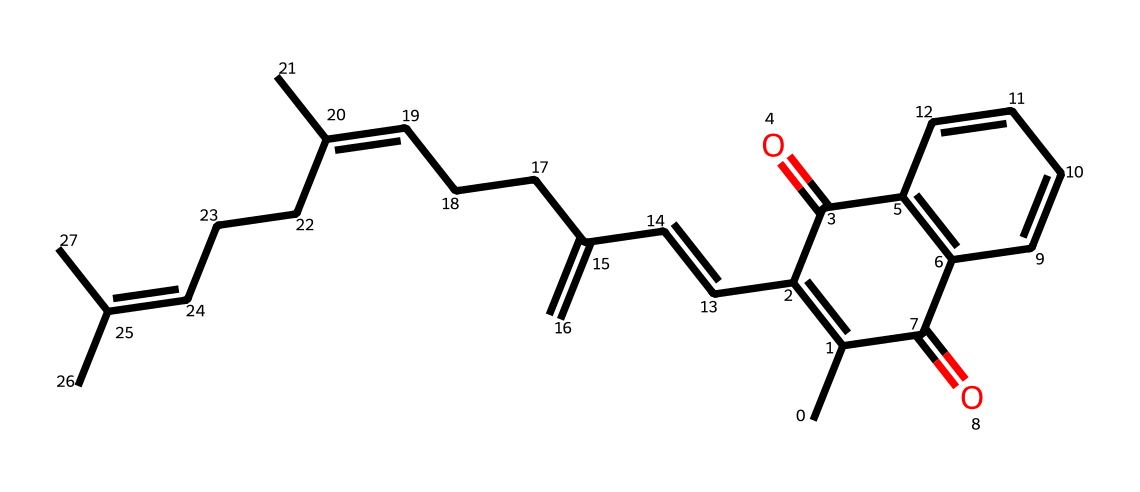What is the name of this chemical? The SMILES representation corresponds to vitamin K, which is essential for blood clotting and bone health.
Answer: vitamin K How many rings are present in the structure? Upon analyzing the structure, there are two distinct cyclic components in the molecule. This can be confirmed by identifying the closed loops in the SMILES representation that indicate cyclic structures.
Answer: 2 How many carbon atoms are in the molecule? The analysis of the SMILES representation reveals that there are a total of 45 carbon atoms, which can be counted from the complete structure represented in the SMILES.
Answer: 45 What type of vitamin is vitamin K classified as? Vitamin K is classified as a fat-soluble vitamin, meaning it dissolves in fats and oils and is stored in the body's fatty tissue.
Answer: fat-soluble What is the characteristic structure that vitamin K contains? The structure of vitamin K contains a naphthoquinone component, which is a common feature of its chemical identity, identifiable through the specific arrangement of carbon and oxygen in its cyclic structure.
Answer: naphthoquinone Which functional groups are present in this vitamin K structure? The structure includes both a quinone group due to the presence of the carbonyl (C=O) groups attached to the aromatic rings, which characterizes its reactivity and biological activity.
Answer: quinone How does vitamin K's chemical structure relate to its biological function? The conjugated double bonds in the structure facilitate electron transfer, which is vital for its role in catalyzing carboxylation reactions that are essential for synthesizing blood-clotting proteins.
Answer: electron transfer 